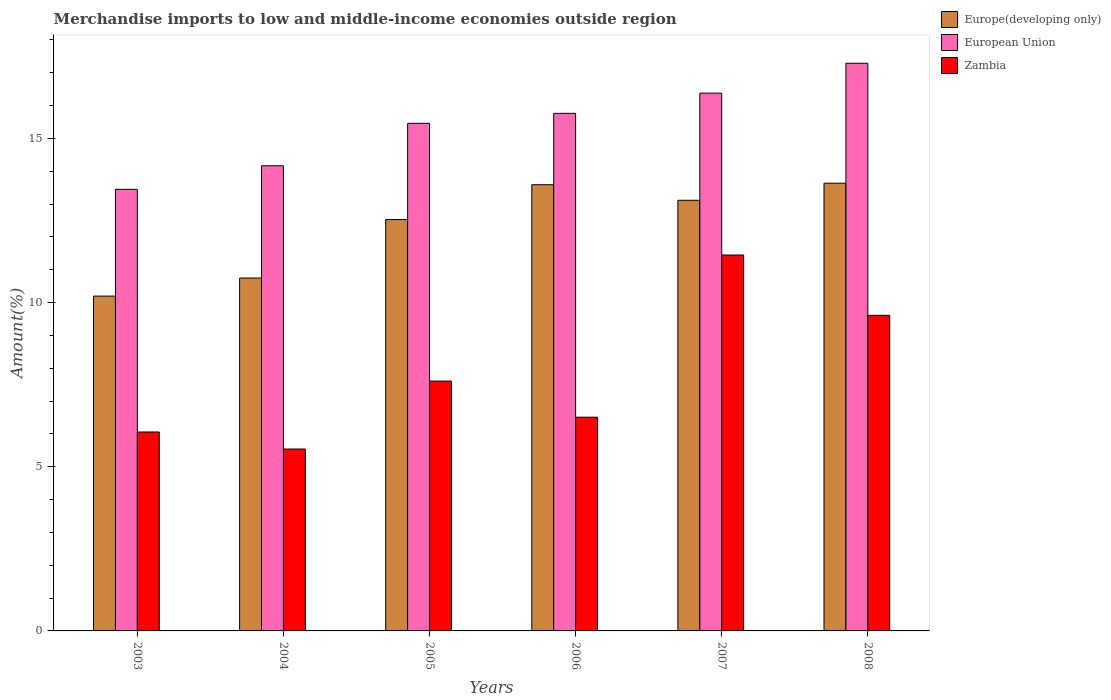Are the number of bars on each tick of the X-axis equal?
Keep it short and to the point. Yes. How many bars are there on the 2nd tick from the left?
Your answer should be very brief. 3. How many bars are there on the 4th tick from the right?
Your answer should be very brief. 3. In how many cases, is the number of bars for a given year not equal to the number of legend labels?
Give a very brief answer. 0. What is the percentage of amount earned from merchandise imports in European Union in 2008?
Give a very brief answer. 17.29. Across all years, what is the maximum percentage of amount earned from merchandise imports in European Union?
Your response must be concise. 17.29. Across all years, what is the minimum percentage of amount earned from merchandise imports in Zambia?
Offer a very short reply. 5.54. In which year was the percentage of amount earned from merchandise imports in Zambia maximum?
Your response must be concise. 2007. What is the total percentage of amount earned from merchandise imports in Zambia in the graph?
Ensure brevity in your answer.  46.78. What is the difference between the percentage of amount earned from merchandise imports in Zambia in 2005 and that in 2006?
Provide a succinct answer. 1.1. What is the difference between the percentage of amount earned from merchandise imports in Zambia in 2003 and the percentage of amount earned from merchandise imports in European Union in 2005?
Give a very brief answer. -9.4. What is the average percentage of amount earned from merchandise imports in European Union per year?
Keep it short and to the point. 15.42. In the year 2003, what is the difference between the percentage of amount earned from merchandise imports in European Union and percentage of amount earned from merchandise imports in Europe(developing only)?
Offer a very short reply. 3.25. What is the ratio of the percentage of amount earned from merchandise imports in Europe(developing only) in 2005 to that in 2008?
Your answer should be compact. 0.92. Is the percentage of amount earned from merchandise imports in Zambia in 2006 less than that in 2007?
Your response must be concise. Yes. What is the difference between the highest and the second highest percentage of amount earned from merchandise imports in Europe(developing only)?
Make the answer very short. 0.05. What is the difference between the highest and the lowest percentage of amount earned from merchandise imports in European Union?
Provide a short and direct response. 3.84. What does the 1st bar from the left in 2003 represents?
Your answer should be very brief. Europe(developing only). What does the 1st bar from the right in 2004 represents?
Your answer should be very brief. Zambia. Is it the case that in every year, the sum of the percentage of amount earned from merchandise imports in Zambia and percentage of amount earned from merchandise imports in Europe(developing only) is greater than the percentage of amount earned from merchandise imports in European Union?
Keep it short and to the point. Yes. What is the difference between two consecutive major ticks on the Y-axis?
Keep it short and to the point. 5. Are the values on the major ticks of Y-axis written in scientific E-notation?
Offer a very short reply. No. Does the graph contain grids?
Your answer should be very brief. No. Where does the legend appear in the graph?
Give a very brief answer. Top right. What is the title of the graph?
Provide a short and direct response. Merchandise imports to low and middle-income economies outside region. Does "Venezuela" appear as one of the legend labels in the graph?
Keep it short and to the point. No. What is the label or title of the X-axis?
Offer a very short reply. Years. What is the label or title of the Y-axis?
Keep it short and to the point. Amount(%). What is the Amount(%) in Europe(developing only) in 2003?
Offer a terse response. 10.2. What is the Amount(%) in European Union in 2003?
Provide a short and direct response. 13.45. What is the Amount(%) of Zambia in 2003?
Ensure brevity in your answer.  6.06. What is the Amount(%) of Europe(developing only) in 2004?
Your answer should be compact. 10.75. What is the Amount(%) in European Union in 2004?
Give a very brief answer. 14.17. What is the Amount(%) of Zambia in 2004?
Keep it short and to the point. 5.54. What is the Amount(%) of Europe(developing only) in 2005?
Ensure brevity in your answer.  12.53. What is the Amount(%) of European Union in 2005?
Offer a terse response. 15.46. What is the Amount(%) of Zambia in 2005?
Offer a very short reply. 7.61. What is the Amount(%) of Europe(developing only) in 2006?
Keep it short and to the point. 13.59. What is the Amount(%) of European Union in 2006?
Your answer should be compact. 15.76. What is the Amount(%) in Zambia in 2006?
Your answer should be very brief. 6.51. What is the Amount(%) of Europe(developing only) in 2007?
Make the answer very short. 13.11. What is the Amount(%) in European Union in 2007?
Make the answer very short. 16.38. What is the Amount(%) of Zambia in 2007?
Ensure brevity in your answer.  11.45. What is the Amount(%) in Europe(developing only) in 2008?
Ensure brevity in your answer.  13.64. What is the Amount(%) in European Union in 2008?
Provide a succinct answer. 17.29. What is the Amount(%) in Zambia in 2008?
Ensure brevity in your answer.  9.61. Across all years, what is the maximum Amount(%) in Europe(developing only)?
Your answer should be compact. 13.64. Across all years, what is the maximum Amount(%) in European Union?
Offer a very short reply. 17.29. Across all years, what is the maximum Amount(%) of Zambia?
Your answer should be compact. 11.45. Across all years, what is the minimum Amount(%) of Europe(developing only)?
Offer a very short reply. 10.2. Across all years, what is the minimum Amount(%) in European Union?
Your answer should be compact. 13.45. Across all years, what is the minimum Amount(%) of Zambia?
Give a very brief answer. 5.54. What is the total Amount(%) in Europe(developing only) in the graph?
Keep it short and to the point. 73.81. What is the total Amount(%) of European Union in the graph?
Your answer should be very brief. 92.5. What is the total Amount(%) of Zambia in the graph?
Make the answer very short. 46.78. What is the difference between the Amount(%) of Europe(developing only) in 2003 and that in 2004?
Offer a terse response. -0.55. What is the difference between the Amount(%) of European Union in 2003 and that in 2004?
Your answer should be very brief. -0.72. What is the difference between the Amount(%) in Zambia in 2003 and that in 2004?
Make the answer very short. 0.52. What is the difference between the Amount(%) of Europe(developing only) in 2003 and that in 2005?
Your answer should be very brief. -2.33. What is the difference between the Amount(%) in European Union in 2003 and that in 2005?
Your answer should be compact. -2.01. What is the difference between the Amount(%) of Zambia in 2003 and that in 2005?
Give a very brief answer. -1.55. What is the difference between the Amount(%) in Europe(developing only) in 2003 and that in 2006?
Give a very brief answer. -3.39. What is the difference between the Amount(%) in European Union in 2003 and that in 2006?
Your answer should be compact. -2.31. What is the difference between the Amount(%) in Zambia in 2003 and that in 2006?
Provide a short and direct response. -0.45. What is the difference between the Amount(%) of Europe(developing only) in 2003 and that in 2007?
Your answer should be very brief. -2.92. What is the difference between the Amount(%) in European Union in 2003 and that in 2007?
Your response must be concise. -2.93. What is the difference between the Amount(%) of Zambia in 2003 and that in 2007?
Provide a short and direct response. -5.39. What is the difference between the Amount(%) of Europe(developing only) in 2003 and that in 2008?
Offer a very short reply. -3.44. What is the difference between the Amount(%) in European Union in 2003 and that in 2008?
Give a very brief answer. -3.84. What is the difference between the Amount(%) in Zambia in 2003 and that in 2008?
Your answer should be compact. -3.55. What is the difference between the Amount(%) in Europe(developing only) in 2004 and that in 2005?
Ensure brevity in your answer.  -1.78. What is the difference between the Amount(%) in European Union in 2004 and that in 2005?
Your answer should be compact. -1.29. What is the difference between the Amount(%) of Zambia in 2004 and that in 2005?
Provide a short and direct response. -2.07. What is the difference between the Amount(%) of Europe(developing only) in 2004 and that in 2006?
Provide a short and direct response. -2.84. What is the difference between the Amount(%) in European Union in 2004 and that in 2006?
Keep it short and to the point. -1.6. What is the difference between the Amount(%) in Zambia in 2004 and that in 2006?
Offer a terse response. -0.97. What is the difference between the Amount(%) in Europe(developing only) in 2004 and that in 2007?
Your response must be concise. -2.37. What is the difference between the Amount(%) in European Union in 2004 and that in 2007?
Provide a succinct answer. -2.21. What is the difference between the Amount(%) in Zambia in 2004 and that in 2007?
Offer a terse response. -5.91. What is the difference between the Amount(%) in Europe(developing only) in 2004 and that in 2008?
Make the answer very short. -2.89. What is the difference between the Amount(%) of European Union in 2004 and that in 2008?
Provide a short and direct response. -3.12. What is the difference between the Amount(%) in Zambia in 2004 and that in 2008?
Your answer should be compact. -4.07. What is the difference between the Amount(%) in Europe(developing only) in 2005 and that in 2006?
Give a very brief answer. -1.06. What is the difference between the Amount(%) of European Union in 2005 and that in 2006?
Offer a terse response. -0.3. What is the difference between the Amount(%) in Zambia in 2005 and that in 2006?
Make the answer very short. 1.1. What is the difference between the Amount(%) in Europe(developing only) in 2005 and that in 2007?
Make the answer very short. -0.59. What is the difference between the Amount(%) of European Union in 2005 and that in 2007?
Your response must be concise. -0.92. What is the difference between the Amount(%) in Zambia in 2005 and that in 2007?
Make the answer very short. -3.84. What is the difference between the Amount(%) in Europe(developing only) in 2005 and that in 2008?
Keep it short and to the point. -1.11. What is the difference between the Amount(%) of European Union in 2005 and that in 2008?
Your answer should be compact. -1.83. What is the difference between the Amount(%) of Zambia in 2005 and that in 2008?
Your response must be concise. -2. What is the difference between the Amount(%) of Europe(developing only) in 2006 and that in 2007?
Make the answer very short. 0.47. What is the difference between the Amount(%) of European Union in 2006 and that in 2007?
Provide a succinct answer. -0.62. What is the difference between the Amount(%) in Zambia in 2006 and that in 2007?
Offer a terse response. -4.94. What is the difference between the Amount(%) of Europe(developing only) in 2006 and that in 2008?
Provide a succinct answer. -0.05. What is the difference between the Amount(%) of European Union in 2006 and that in 2008?
Keep it short and to the point. -1.53. What is the difference between the Amount(%) of Zambia in 2006 and that in 2008?
Offer a terse response. -3.1. What is the difference between the Amount(%) of Europe(developing only) in 2007 and that in 2008?
Give a very brief answer. -0.52. What is the difference between the Amount(%) of European Union in 2007 and that in 2008?
Make the answer very short. -0.91. What is the difference between the Amount(%) of Zambia in 2007 and that in 2008?
Your answer should be very brief. 1.84. What is the difference between the Amount(%) of Europe(developing only) in 2003 and the Amount(%) of European Union in 2004?
Provide a short and direct response. -3.97. What is the difference between the Amount(%) in Europe(developing only) in 2003 and the Amount(%) in Zambia in 2004?
Keep it short and to the point. 4.66. What is the difference between the Amount(%) of European Union in 2003 and the Amount(%) of Zambia in 2004?
Ensure brevity in your answer.  7.91. What is the difference between the Amount(%) in Europe(developing only) in 2003 and the Amount(%) in European Union in 2005?
Your answer should be compact. -5.26. What is the difference between the Amount(%) in Europe(developing only) in 2003 and the Amount(%) in Zambia in 2005?
Your answer should be very brief. 2.59. What is the difference between the Amount(%) in European Union in 2003 and the Amount(%) in Zambia in 2005?
Ensure brevity in your answer.  5.84. What is the difference between the Amount(%) of Europe(developing only) in 2003 and the Amount(%) of European Union in 2006?
Your answer should be very brief. -5.57. What is the difference between the Amount(%) in Europe(developing only) in 2003 and the Amount(%) in Zambia in 2006?
Provide a short and direct response. 3.69. What is the difference between the Amount(%) of European Union in 2003 and the Amount(%) of Zambia in 2006?
Make the answer very short. 6.94. What is the difference between the Amount(%) of Europe(developing only) in 2003 and the Amount(%) of European Union in 2007?
Provide a short and direct response. -6.18. What is the difference between the Amount(%) of Europe(developing only) in 2003 and the Amount(%) of Zambia in 2007?
Your answer should be very brief. -1.25. What is the difference between the Amount(%) in European Union in 2003 and the Amount(%) in Zambia in 2007?
Offer a very short reply. 2. What is the difference between the Amount(%) in Europe(developing only) in 2003 and the Amount(%) in European Union in 2008?
Provide a succinct answer. -7.09. What is the difference between the Amount(%) of Europe(developing only) in 2003 and the Amount(%) of Zambia in 2008?
Your answer should be compact. 0.59. What is the difference between the Amount(%) in European Union in 2003 and the Amount(%) in Zambia in 2008?
Make the answer very short. 3.84. What is the difference between the Amount(%) of Europe(developing only) in 2004 and the Amount(%) of European Union in 2005?
Provide a succinct answer. -4.71. What is the difference between the Amount(%) in Europe(developing only) in 2004 and the Amount(%) in Zambia in 2005?
Offer a terse response. 3.14. What is the difference between the Amount(%) in European Union in 2004 and the Amount(%) in Zambia in 2005?
Make the answer very short. 6.56. What is the difference between the Amount(%) of Europe(developing only) in 2004 and the Amount(%) of European Union in 2006?
Offer a terse response. -5.02. What is the difference between the Amount(%) of Europe(developing only) in 2004 and the Amount(%) of Zambia in 2006?
Offer a very short reply. 4.24. What is the difference between the Amount(%) in European Union in 2004 and the Amount(%) in Zambia in 2006?
Keep it short and to the point. 7.66. What is the difference between the Amount(%) in Europe(developing only) in 2004 and the Amount(%) in European Union in 2007?
Ensure brevity in your answer.  -5.63. What is the difference between the Amount(%) of Europe(developing only) in 2004 and the Amount(%) of Zambia in 2007?
Your response must be concise. -0.7. What is the difference between the Amount(%) of European Union in 2004 and the Amount(%) of Zambia in 2007?
Provide a succinct answer. 2.72. What is the difference between the Amount(%) of Europe(developing only) in 2004 and the Amount(%) of European Union in 2008?
Your response must be concise. -6.54. What is the difference between the Amount(%) in Europe(developing only) in 2004 and the Amount(%) in Zambia in 2008?
Offer a very short reply. 1.14. What is the difference between the Amount(%) of European Union in 2004 and the Amount(%) of Zambia in 2008?
Your answer should be very brief. 4.55. What is the difference between the Amount(%) in Europe(developing only) in 2005 and the Amount(%) in European Union in 2006?
Keep it short and to the point. -3.23. What is the difference between the Amount(%) of Europe(developing only) in 2005 and the Amount(%) of Zambia in 2006?
Your answer should be very brief. 6.02. What is the difference between the Amount(%) in European Union in 2005 and the Amount(%) in Zambia in 2006?
Keep it short and to the point. 8.95. What is the difference between the Amount(%) of Europe(developing only) in 2005 and the Amount(%) of European Union in 2007?
Your response must be concise. -3.85. What is the difference between the Amount(%) in Europe(developing only) in 2005 and the Amount(%) in Zambia in 2007?
Offer a very short reply. 1.08. What is the difference between the Amount(%) of European Union in 2005 and the Amount(%) of Zambia in 2007?
Give a very brief answer. 4.01. What is the difference between the Amount(%) in Europe(developing only) in 2005 and the Amount(%) in European Union in 2008?
Offer a very short reply. -4.76. What is the difference between the Amount(%) of Europe(developing only) in 2005 and the Amount(%) of Zambia in 2008?
Provide a short and direct response. 2.92. What is the difference between the Amount(%) of European Union in 2005 and the Amount(%) of Zambia in 2008?
Ensure brevity in your answer.  5.85. What is the difference between the Amount(%) in Europe(developing only) in 2006 and the Amount(%) in European Union in 2007?
Your answer should be very brief. -2.79. What is the difference between the Amount(%) of Europe(developing only) in 2006 and the Amount(%) of Zambia in 2007?
Your answer should be compact. 2.14. What is the difference between the Amount(%) in European Union in 2006 and the Amount(%) in Zambia in 2007?
Offer a very short reply. 4.31. What is the difference between the Amount(%) of Europe(developing only) in 2006 and the Amount(%) of European Union in 2008?
Make the answer very short. -3.7. What is the difference between the Amount(%) of Europe(developing only) in 2006 and the Amount(%) of Zambia in 2008?
Make the answer very short. 3.98. What is the difference between the Amount(%) of European Union in 2006 and the Amount(%) of Zambia in 2008?
Offer a terse response. 6.15. What is the difference between the Amount(%) in Europe(developing only) in 2007 and the Amount(%) in European Union in 2008?
Give a very brief answer. -4.17. What is the difference between the Amount(%) of Europe(developing only) in 2007 and the Amount(%) of Zambia in 2008?
Give a very brief answer. 3.5. What is the difference between the Amount(%) in European Union in 2007 and the Amount(%) in Zambia in 2008?
Give a very brief answer. 6.77. What is the average Amount(%) of Europe(developing only) per year?
Provide a short and direct response. 12.3. What is the average Amount(%) of European Union per year?
Offer a very short reply. 15.42. What is the average Amount(%) of Zambia per year?
Provide a short and direct response. 7.8. In the year 2003, what is the difference between the Amount(%) in Europe(developing only) and Amount(%) in European Union?
Give a very brief answer. -3.25. In the year 2003, what is the difference between the Amount(%) of Europe(developing only) and Amount(%) of Zambia?
Ensure brevity in your answer.  4.14. In the year 2003, what is the difference between the Amount(%) in European Union and Amount(%) in Zambia?
Your response must be concise. 7.39. In the year 2004, what is the difference between the Amount(%) of Europe(developing only) and Amount(%) of European Union?
Ensure brevity in your answer.  -3.42. In the year 2004, what is the difference between the Amount(%) of Europe(developing only) and Amount(%) of Zambia?
Make the answer very short. 5.21. In the year 2004, what is the difference between the Amount(%) of European Union and Amount(%) of Zambia?
Your answer should be compact. 8.63. In the year 2005, what is the difference between the Amount(%) of Europe(developing only) and Amount(%) of European Union?
Your response must be concise. -2.93. In the year 2005, what is the difference between the Amount(%) in Europe(developing only) and Amount(%) in Zambia?
Provide a succinct answer. 4.92. In the year 2005, what is the difference between the Amount(%) in European Union and Amount(%) in Zambia?
Provide a short and direct response. 7.85. In the year 2006, what is the difference between the Amount(%) in Europe(developing only) and Amount(%) in European Union?
Ensure brevity in your answer.  -2.17. In the year 2006, what is the difference between the Amount(%) of Europe(developing only) and Amount(%) of Zambia?
Make the answer very short. 7.08. In the year 2006, what is the difference between the Amount(%) of European Union and Amount(%) of Zambia?
Your response must be concise. 9.25. In the year 2007, what is the difference between the Amount(%) in Europe(developing only) and Amount(%) in European Union?
Your response must be concise. -3.26. In the year 2007, what is the difference between the Amount(%) of Europe(developing only) and Amount(%) of Zambia?
Your response must be concise. 1.67. In the year 2007, what is the difference between the Amount(%) in European Union and Amount(%) in Zambia?
Offer a very short reply. 4.93. In the year 2008, what is the difference between the Amount(%) of Europe(developing only) and Amount(%) of European Union?
Ensure brevity in your answer.  -3.65. In the year 2008, what is the difference between the Amount(%) of Europe(developing only) and Amount(%) of Zambia?
Your answer should be compact. 4.02. In the year 2008, what is the difference between the Amount(%) of European Union and Amount(%) of Zambia?
Offer a very short reply. 7.68. What is the ratio of the Amount(%) in Europe(developing only) in 2003 to that in 2004?
Your answer should be compact. 0.95. What is the ratio of the Amount(%) of European Union in 2003 to that in 2004?
Your response must be concise. 0.95. What is the ratio of the Amount(%) of Zambia in 2003 to that in 2004?
Offer a terse response. 1.09. What is the ratio of the Amount(%) of Europe(developing only) in 2003 to that in 2005?
Your answer should be very brief. 0.81. What is the ratio of the Amount(%) in European Union in 2003 to that in 2005?
Offer a terse response. 0.87. What is the ratio of the Amount(%) in Zambia in 2003 to that in 2005?
Offer a very short reply. 0.8. What is the ratio of the Amount(%) in Europe(developing only) in 2003 to that in 2006?
Offer a terse response. 0.75. What is the ratio of the Amount(%) in European Union in 2003 to that in 2006?
Ensure brevity in your answer.  0.85. What is the ratio of the Amount(%) of Zambia in 2003 to that in 2006?
Your response must be concise. 0.93. What is the ratio of the Amount(%) in Europe(developing only) in 2003 to that in 2007?
Your answer should be very brief. 0.78. What is the ratio of the Amount(%) in European Union in 2003 to that in 2007?
Keep it short and to the point. 0.82. What is the ratio of the Amount(%) of Zambia in 2003 to that in 2007?
Keep it short and to the point. 0.53. What is the ratio of the Amount(%) of Europe(developing only) in 2003 to that in 2008?
Ensure brevity in your answer.  0.75. What is the ratio of the Amount(%) in European Union in 2003 to that in 2008?
Your answer should be compact. 0.78. What is the ratio of the Amount(%) in Zambia in 2003 to that in 2008?
Your answer should be compact. 0.63. What is the ratio of the Amount(%) in Europe(developing only) in 2004 to that in 2005?
Your response must be concise. 0.86. What is the ratio of the Amount(%) of European Union in 2004 to that in 2005?
Ensure brevity in your answer.  0.92. What is the ratio of the Amount(%) in Zambia in 2004 to that in 2005?
Offer a very short reply. 0.73. What is the ratio of the Amount(%) of Europe(developing only) in 2004 to that in 2006?
Your answer should be very brief. 0.79. What is the ratio of the Amount(%) of European Union in 2004 to that in 2006?
Offer a terse response. 0.9. What is the ratio of the Amount(%) in Zambia in 2004 to that in 2006?
Offer a terse response. 0.85. What is the ratio of the Amount(%) in Europe(developing only) in 2004 to that in 2007?
Your answer should be compact. 0.82. What is the ratio of the Amount(%) of European Union in 2004 to that in 2007?
Make the answer very short. 0.86. What is the ratio of the Amount(%) in Zambia in 2004 to that in 2007?
Provide a short and direct response. 0.48. What is the ratio of the Amount(%) in Europe(developing only) in 2004 to that in 2008?
Your answer should be very brief. 0.79. What is the ratio of the Amount(%) of European Union in 2004 to that in 2008?
Your answer should be very brief. 0.82. What is the ratio of the Amount(%) in Zambia in 2004 to that in 2008?
Provide a succinct answer. 0.58. What is the ratio of the Amount(%) in Europe(developing only) in 2005 to that in 2006?
Offer a very short reply. 0.92. What is the ratio of the Amount(%) in European Union in 2005 to that in 2006?
Provide a short and direct response. 0.98. What is the ratio of the Amount(%) in Zambia in 2005 to that in 2006?
Ensure brevity in your answer.  1.17. What is the ratio of the Amount(%) in Europe(developing only) in 2005 to that in 2007?
Offer a terse response. 0.96. What is the ratio of the Amount(%) of European Union in 2005 to that in 2007?
Ensure brevity in your answer.  0.94. What is the ratio of the Amount(%) in Zambia in 2005 to that in 2007?
Keep it short and to the point. 0.66. What is the ratio of the Amount(%) of Europe(developing only) in 2005 to that in 2008?
Provide a succinct answer. 0.92. What is the ratio of the Amount(%) of European Union in 2005 to that in 2008?
Provide a short and direct response. 0.89. What is the ratio of the Amount(%) of Zambia in 2005 to that in 2008?
Offer a very short reply. 0.79. What is the ratio of the Amount(%) of Europe(developing only) in 2006 to that in 2007?
Your response must be concise. 1.04. What is the ratio of the Amount(%) in European Union in 2006 to that in 2007?
Keep it short and to the point. 0.96. What is the ratio of the Amount(%) in Zambia in 2006 to that in 2007?
Keep it short and to the point. 0.57. What is the ratio of the Amount(%) in Europe(developing only) in 2006 to that in 2008?
Offer a terse response. 1. What is the ratio of the Amount(%) in European Union in 2006 to that in 2008?
Give a very brief answer. 0.91. What is the ratio of the Amount(%) in Zambia in 2006 to that in 2008?
Make the answer very short. 0.68. What is the ratio of the Amount(%) in Europe(developing only) in 2007 to that in 2008?
Make the answer very short. 0.96. What is the ratio of the Amount(%) in Zambia in 2007 to that in 2008?
Provide a succinct answer. 1.19. What is the difference between the highest and the second highest Amount(%) in Europe(developing only)?
Provide a short and direct response. 0.05. What is the difference between the highest and the second highest Amount(%) of Zambia?
Give a very brief answer. 1.84. What is the difference between the highest and the lowest Amount(%) of Europe(developing only)?
Ensure brevity in your answer.  3.44. What is the difference between the highest and the lowest Amount(%) in European Union?
Your answer should be very brief. 3.84. What is the difference between the highest and the lowest Amount(%) in Zambia?
Your response must be concise. 5.91. 